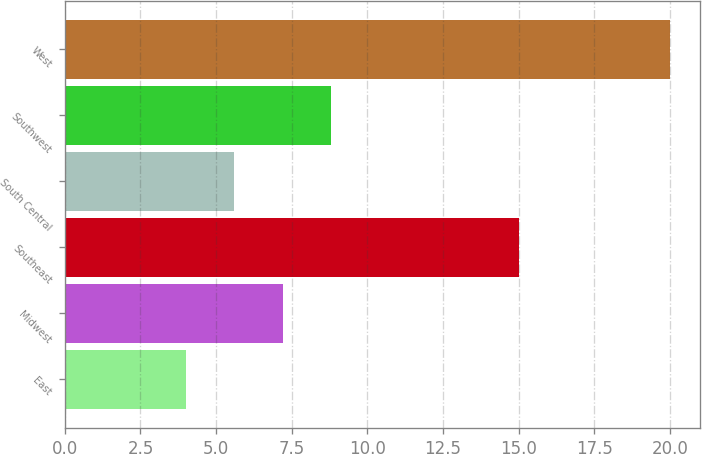<chart> <loc_0><loc_0><loc_500><loc_500><bar_chart><fcel>East<fcel>Midwest<fcel>Southeast<fcel>South Central<fcel>Southwest<fcel>West<nl><fcel>4<fcel>7.2<fcel>15<fcel>5.6<fcel>8.8<fcel>20<nl></chart> 